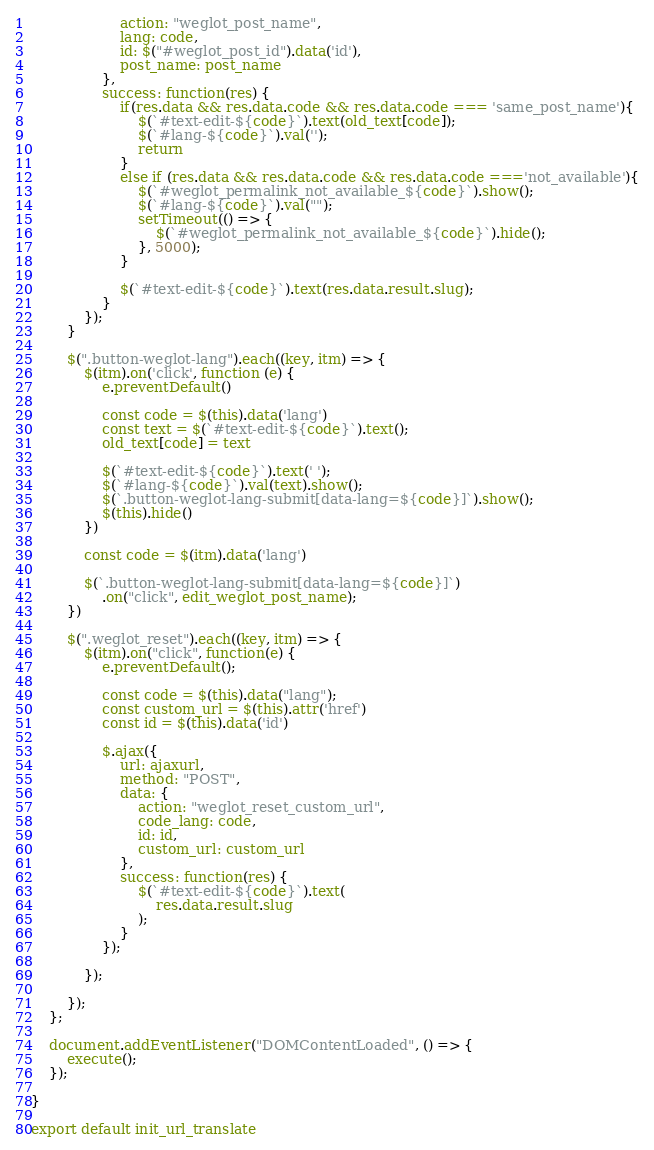<code> <loc_0><loc_0><loc_500><loc_500><_JavaScript_>					action: "weglot_post_name",
					lang: code,
					id: $("#weglot_post_id").data('id'),
					post_name: post_name
				},
				success: function(res) {
					if(res.data && res.data.code && res.data.code === 'same_post_name'){
						$(`#text-edit-${code}`).text(old_text[code]);
						$(`#lang-${code}`).val('');
						return
					}
					else if (res.data && res.data.code && res.data.code ==='not_available'){
						$(`#weglot_permalink_not_available_${code}`).show();
						$(`#lang-${code}`).val("");
						setTimeout(() => {
							$(`#weglot_permalink_not_available_${code}`).hide();
						}, 5000);
					}

					$(`#text-edit-${code}`).text(res.data.result.slug);
				}
			});
		}

		$(".button-weglot-lang").each((key, itm) => {
			$(itm).on('click', function (e) {
				e.preventDefault()

				const code = $(this).data('lang')
				const text = $(`#text-edit-${code}`).text();
				old_text[code] = text

				$(`#text-edit-${code}`).text(' ');
				$(`#lang-${code}`).val(text).show();
				$(`.button-weglot-lang-submit[data-lang=${code}]`).show();
				$(this).hide()
			})

			const code = $(itm).data('lang')

			$(`.button-weglot-lang-submit[data-lang=${code}]`)
				.on("click", edit_weglot_post_name);
		})

		$(".weglot_reset").each((key, itm) => {
			$(itm).on("click", function(e) {
				e.preventDefault();

				const code = $(this).data("lang");
				const custom_url = $(this).attr('href')
				const id = $(this).data('id')

				$.ajax({
					url: ajaxurl,
					method: "POST",
					data: {
						action: "weglot_reset_custom_url",
						code_lang: code,
						id: id,
						custom_url: custom_url
					},
					success: function(res) {
						$(`#text-edit-${code}`).text(
							res.data.result.slug
						);
					}
				});

			});

		});
	};

	document.addEventListener("DOMContentLoaded", () => {
		execute();
	});

}

export default init_url_translate
</code> 